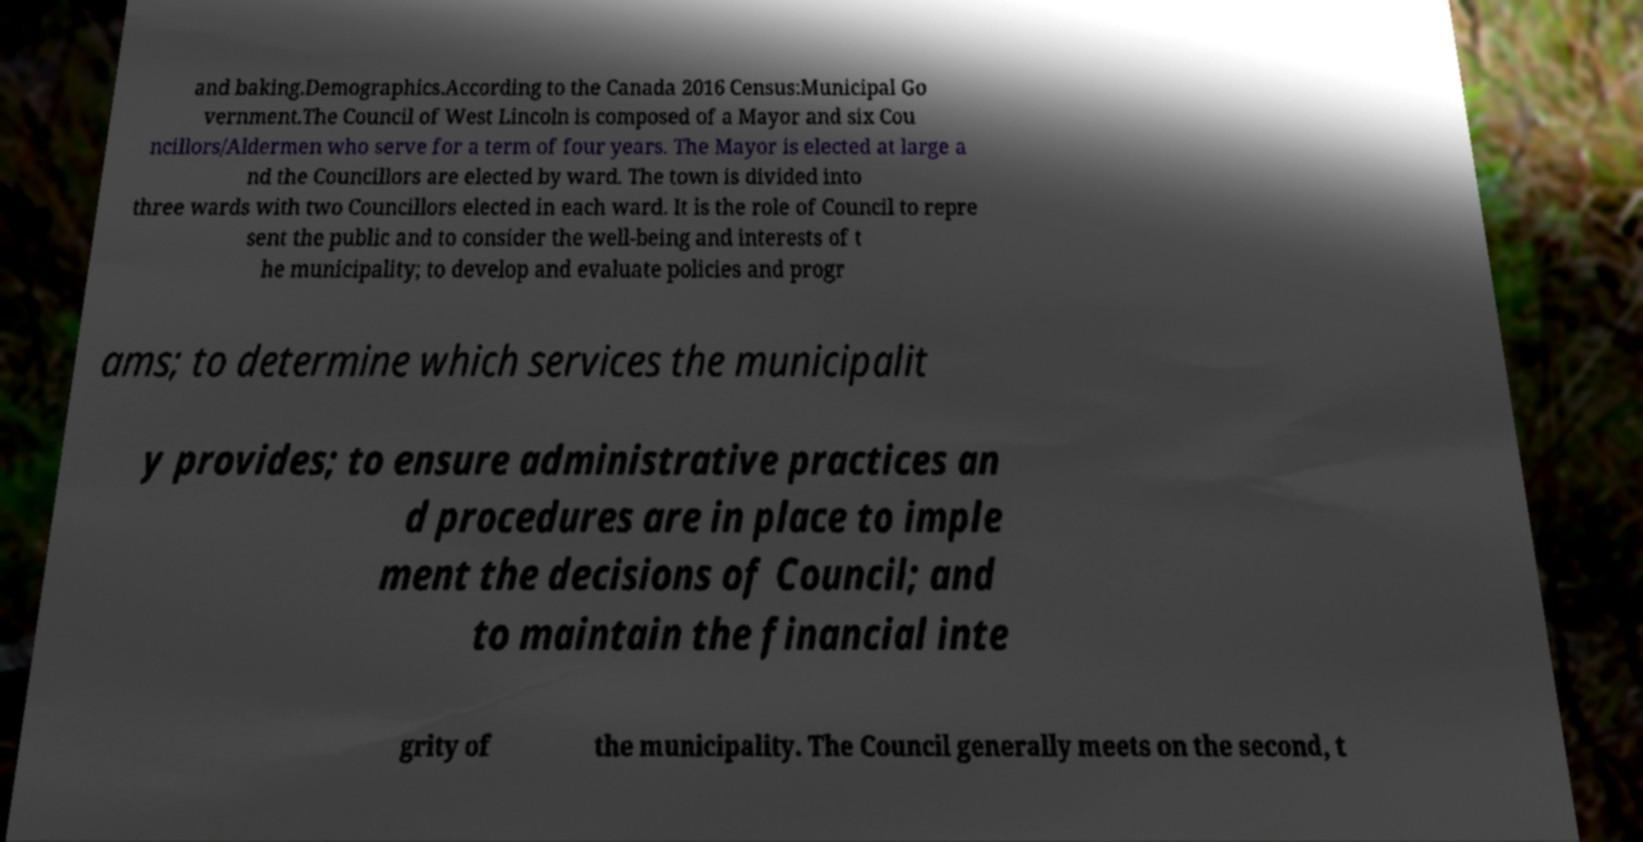Could you assist in decoding the text presented in this image and type it out clearly? and baking.Demographics.According to the Canada 2016 Census:Municipal Go vernment.The Council of West Lincoln is composed of a Mayor and six Cou ncillors/Aldermen who serve for a term of four years. The Mayor is elected at large a nd the Councillors are elected by ward. The town is divided into three wards with two Councillors elected in each ward. It is the role of Council to repre sent the public and to consider the well-being and interests of t he municipality; to develop and evaluate policies and progr ams; to determine which services the municipalit y provides; to ensure administrative practices an d procedures are in place to imple ment the decisions of Council; and to maintain the financial inte grity of the municipality. The Council generally meets on the second, t 